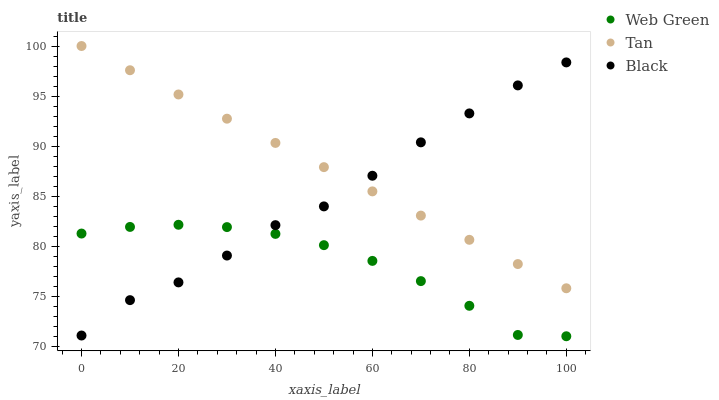Does Web Green have the minimum area under the curve?
Answer yes or no. Yes. Does Tan have the maximum area under the curve?
Answer yes or no. Yes. Does Black have the minimum area under the curve?
Answer yes or no. No. Does Black have the maximum area under the curve?
Answer yes or no. No. Is Tan the smoothest?
Answer yes or no. Yes. Is Black the roughest?
Answer yes or no. Yes. Is Web Green the smoothest?
Answer yes or no. No. Is Web Green the roughest?
Answer yes or no. No. Does Web Green have the lowest value?
Answer yes or no. Yes. Does Black have the lowest value?
Answer yes or no. No. Does Tan have the highest value?
Answer yes or no. Yes. Does Black have the highest value?
Answer yes or no. No. Is Web Green less than Tan?
Answer yes or no. Yes. Is Tan greater than Web Green?
Answer yes or no. Yes. Does Black intersect Web Green?
Answer yes or no. Yes. Is Black less than Web Green?
Answer yes or no. No. Is Black greater than Web Green?
Answer yes or no. No. Does Web Green intersect Tan?
Answer yes or no. No. 